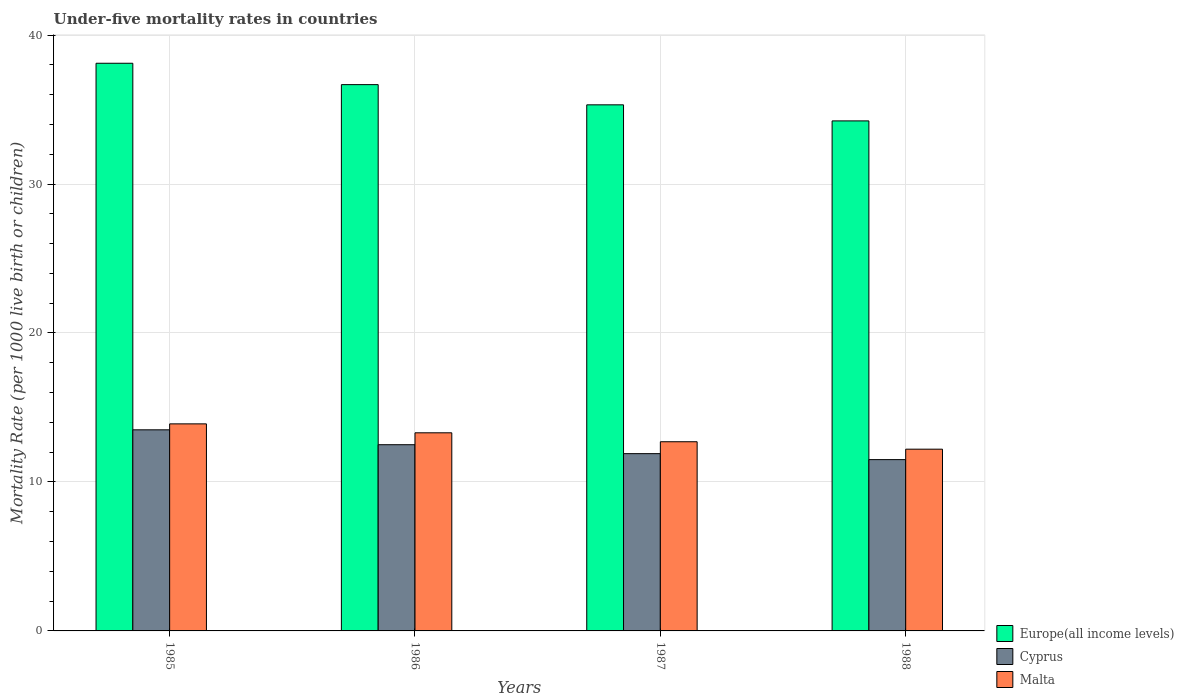How many different coloured bars are there?
Ensure brevity in your answer.  3. How many groups of bars are there?
Ensure brevity in your answer.  4. How many bars are there on the 2nd tick from the right?
Provide a succinct answer. 3. In how many cases, is the number of bars for a given year not equal to the number of legend labels?
Provide a short and direct response. 0. What is the under-five mortality rate in Cyprus in 1988?
Provide a short and direct response. 11.5. Across all years, what is the minimum under-five mortality rate in Malta?
Provide a short and direct response. 12.2. In which year was the under-five mortality rate in Malta maximum?
Ensure brevity in your answer.  1985. In which year was the under-five mortality rate in Europe(all income levels) minimum?
Your answer should be compact. 1988. What is the total under-five mortality rate in Europe(all income levels) in the graph?
Your response must be concise. 144.33. What is the difference between the under-five mortality rate in Europe(all income levels) in 1988 and the under-five mortality rate in Cyprus in 1986?
Make the answer very short. 21.74. What is the average under-five mortality rate in Europe(all income levels) per year?
Your response must be concise. 36.08. In the year 1988, what is the difference between the under-five mortality rate in Cyprus and under-five mortality rate in Europe(all income levels)?
Offer a very short reply. -22.74. What is the ratio of the under-five mortality rate in Europe(all income levels) in 1987 to that in 1988?
Keep it short and to the point. 1.03. What is the difference between the highest and the lowest under-five mortality rate in Malta?
Give a very brief answer. 1.7. In how many years, is the under-five mortality rate in Europe(all income levels) greater than the average under-five mortality rate in Europe(all income levels) taken over all years?
Your response must be concise. 2. Is the sum of the under-five mortality rate in Cyprus in 1985 and 1987 greater than the maximum under-five mortality rate in Europe(all income levels) across all years?
Keep it short and to the point. No. What does the 3rd bar from the left in 1986 represents?
Provide a succinct answer. Malta. What does the 2nd bar from the right in 1988 represents?
Ensure brevity in your answer.  Cyprus. Is it the case that in every year, the sum of the under-five mortality rate in Malta and under-five mortality rate in Europe(all income levels) is greater than the under-five mortality rate in Cyprus?
Give a very brief answer. Yes. Are all the bars in the graph horizontal?
Offer a terse response. No. What is the difference between two consecutive major ticks on the Y-axis?
Ensure brevity in your answer.  10. Does the graph contain any zero values?
Ensure brevity in your answer.  No. Does the graph contain grids?
Ensure brevity in your answer.  Yes. How many legend labels are there?
Provide a short and direct response. 3. What is the title of the graph?
Provide a succinct answer. Under-five mortality rates in countries. What is the label or title of the Y-axis?
Give a very brief answer. Mortality Rate (per 1000 live birth or children). What is the Mortality Rate (per 1000 live birth or children) of Europe(all income levels) in 1985?
Provide a short and direct response. 38.11. What is the Mortality Rate (per 1000 live birth or children) in Europe(all income levels) in 1986?
Your answer should be compact. 36.67. What is the Mortality Rate (per 1000 live birth or children) of Cyprus in 1986?
Provide a succinct answer. 12.5. What is the Mortality Rate (per 1000 live birth or children) of Europe(all income levels) in 1987?
Your response must be concise. 35.32. What is the Mortality Rate (per 1000 live birth or children) in Cyprus in 1987?
Your answer should be compact. 11.9. What is the Mortality Rate (per 1000 live birth or children) of Europe(all income levels) in 1988?
Keep it short and to the point. 34.24. What is the Mortality Rate (per 1000 live birth or children) of Cyprus in 1988?
Your answer should be very brief. 11.5. Across all years, what is the maximum Mortality Rate (per 1000 live birth or children) of Europe(all income levels)?
Your answer should be compact. 38.11. Across all years, what is the maximum Mortality Rate (per 1000 live birth or children) in Malta?
Provide a short and direct response. 13.9. Across all years, what is the minimum Mortality Rate (per 1000 live birth or children) in Europe(all income levels)?
Give a very brief answer. 34.24. Across all years, what is the minimum Mortality Rate (per 1000 live birth or children) of Cyprus?
Provide a short and direct response. 11.5. Across all years, what is the minimum Mortality Rate (per 1000 live birth or children) of Malta?
Ensure brevity in your answer.  12.2. What is the total Mortality Rate (per 1000 live birth or children) in Europe(all income levels) in the graph?
Your answer should be very brief. 144.33. What is the total Mortality Rate (per 1000 live birth or children) in Cyprus in the graph?
Your answer should be compact. 49.4. What is the total Mortality Rate (per 1000 live birth or children) in Malta in the graph?
Offer a terse response. 52.1. What is the difference between the Mortality Rate (per 1000 live birth or children) in Europe(all income levels) in 1985 and that in 1986?
Your answer should be compact. 1.44. What is the difference between the Mortality Rate (per 1000 live birth or children) of Cyprus in 1985 and that in 1986?
Your answer should be very brief. 1. What is the difference between the Mortality Rate (per 1000 live birth or children) in Europe(all income levels) in 1985 and that in 1987?
Provide a short and direct response. 2.79. What is the difference between the Mortality Rate (per 1000 live birth or children) of Europe(all income levels) in 1985 and that in 1988?
Your answer should be very brief. 3.87. What is the difference between the Mortality Rate (per 1000 live birth or children) in Europe(all income levels) in 1986 and that in 1987?
Your answer should be very brief. 1.36. What is the difference between the Mortality Rate (per 1000 live birth or children) of Malta in 1986 and that in 1987?
Ensure brevity in your answer.  0.6. What is the difference between the Mortality Rate (per 1000 live birth or children) in Europe(all income levels) in 1986 and that in 1988?
Keep it short and to the point. 2.43. What is the difference between the Mortality Rate (per 1000 live birth or children) in Cyprus in 1986 and that in 1988?
Provide a short and direct response. 1. What is the difference between the Mortality Rate (per 1000 live birth or children) in Europe(all income levels) in 1987 and that in 1988?
Your answer should be very brief. 1.08. What is the difference between the Mortality Rate (per 1000 live birth or children) in Cyprus in 1987 and that in 1988?
Your answer should be very brief. 0.4. What is the difference between the Mortality Rate (per 1000 live birth or children) of Europe(all income levels) in 1985 and the Mortality Rate (per 1000 live birth or children) of Cyprus in 1986?
Ensure brevity in your answer.  25.61. What is the difference between the Mortality Rate (per 1000 live birth or children) in Europe(all income levels) in 1985 and the Mortality Rate (per 1000 live birth or children) in Malta in 1986?
Offer a very short reply. 24.81. What is the difference between the Mortality Rate (per 1000 live birth or children) in Cyprus in 1985 and the Mortality Rate (per 1000 live birth or children) in Malta in 1986?
Your answer should be very brief. 0.2. What is the difference between the Mortality Rate (per 1000 live birth or children) of Europe(all income levels) in 1985 and the Mortality Rate (per 1000 live birth or children) of Cyprus in 1987?
Your response must be concise. 26.21. What is the difference between the Mortality Rate (per 1000 live birth or children) in Europe(all income levels) in 1985 and the Mortality Rate (per 1000 live birth or children) in Malta in 1987?
Your answer should be very brief. 25.41. What is the difference between the Mortality Rate (per 1000 live birth or children) of Cyprus in 1985 and the Mortality Rate (per 1000 live birth or children) of Malta in 1987?
Offer a terse response. 0.8. What is the difference between the Mortality Rate (per 1000 live birth or children) in Europe(all income levels) in 1985 and the Mortality Rate (per 1000 live birth or children) in Cyprus in 1988?
Make the answer very short. 26.61. What is the difference between the Mortality Rate (per 1000 live birth or children) in Europe(all income levels) in 1985 and the Mortality Rate (per 1000 live birth or children) in Malta in 1988?
Give a very brief answer. 25.91. What is the difference between the Mortality Rate (per 1000 live birth or children) of Cyprus in 1985 and the Mortality Rate (per 1000 live birth or children) of Malta in 1988?
Your response must be concise. 1.3. What is the difference between the Mortality Rate (per 1000 live birth or children) in Europe(all income levels) in 1986 and the Mortality Rate (per 1000 live birth or children) in Cyprus in 1987?
Provide a succinct answer. 24.77. What is the difference between the Mortality Rate (per 1000 live birth or children) in Europe(all income levels) in 1986 and the Mortality Rate (per 1000 live birth or children) in Malta in 1987?
Provide a short and direct response. 23.97. What is the difference between the Mortality Rate (per 1000 live birth or children) in Europe(all income levels) in 1986 and the Mortality Rate (per 1000 live birth or children) in Cyprus in 1988?
Provide a short and direct response. 25.17. What is the difference between the Mortality Rate (per 1000 live birth or children) in Europe(all income levels) in 1986 and the Mortality Rate (per 1000 live birth or children) in Malta in 1988?
Provide a succinct answer. 24.47. What is the difference between the Mortality Rate (per 1000 live birth or children) of Cyprus in 1986 and the Mortality Rate (per 1000 live birth or children) of Malta in 1988?
Keep it short and to the point. 0.3. What is the difference between the Mortality Rate (per 1000 live birth or children) of Europe(all income levels) in 1987 and the Mortality Rate (per 1000 live birth or children) of Cyprus in 1988?
Make the answer very short. 23.82. What is the difference between the Mortality Rate (per 1000 live birth or children) of Europe(all income levels) in 1987 and the Mortality Rate (per 1000 live birth or children) of Malta in 1988?
Offer a terse response. 23.12. What is the average Mortality Rate (per 1000 live birth or children) in Europe(all income levels) per year?
Give a very brief answer. 36.08. What is the average Mortality Rate (per 1000 live birth or children) of Cyprus per year?
Ensure brevity in your answer.  12.35. What is the average Mortality Rate (per 1000 live birth or children) in Malta per year?
Provide a short and direct response. 13.03. In the year 1985, what is the difference between the Mortality Rate (per 1000 live birth or children) of Europe(all income levels) and Mortality Rate (per 1000 live birth or children) of Cyprus?
Make the answer very short. 24.61. In the year 1985, what is the difference between the Mortality Rate (per 1000 live birth or children) of Europe(all income levels) and Mortality Rate (per 1000 live birth or children) of Malta?
Keep it short and to the point. 24.21. In the year 1985, what is the difference between the Mortality Rate (per 1000 live birth or children) in Cyprus and Mortality Rate (per 1000 live birth or children) in Malta?
Make the answer very short. -0.4. In the year 1986, what is the difference between the Mortality Rate (per 1000 live birth or children) of Europe(all income levels) and Mortality Rate (per 1000 live birth or children) of Cyprus?
Offer a terse response. 24.17. In the year 1986, what is the difference between the Mortality Rate (per 1000 live birth or children) of Europe(all income levels) and Mortality Rate (per 1000 live birth or children) of Malta?
Offer a very short reply. 23.37. In the year 1987, what is the difference between the Mortality Rate (per 1000 live birth or children) of Europe(all income levels) and Mortality Rate (per 1000 live birth or children) of Cyprus?
Offer a terse response. 23.42. In the year 1987, what is the difference between the Mortality Rate (per 1000 live birth or children) in Europe(all income levels) and Mortality Rate (per 1000 live birth or children) in Malta?
Offer a terse response. 22.62. In the year 1988, what is the difference between the Mortality Rate (per 1000 live birth or children) of Europe(all income levels) and Mortality Rate (per 1000 live birth or children) of Cyprus?
Provide a short and direct response. 22.74. In the year 1988, what is the difference between the Mortality Rate (per 1000 live birth or children) in Europe(all income levels) and Mortality Rate (per 1000 live birth or children) in Malta?
Ensure brevity in your answer.  22.04. In the year 1988, what is the difference between the Mortality Rate (per 1000 live birth or children) in Cyprus and Mortality Rate (per 1000 live birth or children) in Malta?
Give a very brief answer. -0.7. What is the ratio of the Mortality Rate (per 1000 live birth or children) of Europe(all income levels) in 1985 to that in 1986?
Provide a succinct answer. 1.04. What is the ratio of the Mortality Rate (per 1000 live birth or children) in Malta in 1985 to that in 1986?
Ensure brevity in your answer.  1.05. What is the ratio of the Mortality Rate (per 1000 live birth or children) in Europe(all income levels) in 1985 to that in 1987?
Offer a terse response. 1.08. What is the ratio of the Mortality Rate (per 1000 live birth or children) in Cyprus in 1985 to that in 1987?
Give a very brief answer. 1.13. What is the ratio of the Mortality Rate (per 1000 live birth or children) of Malta in 1985 to that in 1987?
Keep it short and to the point. 1.09. What is the ratio of the Mortality Rate (per 1000 live birth or children) of Europe(all income levels) in 1985 to that in 1988?
Make the answer very short. 1.11. What is the ratio of the Mortality Rate (per 1000 live birth or children) of Cyprus in 1985 to that in 1988?
Keep it short and to the point. 1.17. What is the ratio of the Mortality Rate (per 1000 live birth or children) of Malta in 1985 to that in 1988?
Provide a short and direct response. 1.14. What is the ratio of the Mortality Rate (per 1000 live birth or children) of Europe(all income levels) in 1986 to that in 1987?
Keep it short and to the point. 1.04. What is the ratio of the Mortality Rate (per 1000 live birth or children) of Cyprus in 1986 to that in 1987?
Provide a succinct answer. 1.05. What is the ratio of the Mortality Rate (per 1000 live birth or children) in Malta in 1986 to that in 1987?
Your answer should be very brief. 1.05. What is the ratio of the Mortality Rate (per 1000 live birth or children) in Europe(all income levels) in 1986 to that in 1988?
Ensure brevity in your answer.  1.07. What is the ratio of the Mortality Rate (per 1000 live birth or children) in Cyprus in 1986 to that in 1988?
Your response must be concise. 1.09. What is the ratio of the Mortality Rate (per 1000 live birth or children) of Malta in 1986 to that in 1988?
Provide a succinct answer. 1.09. What is the ratio of the Mortality Rate (per 1000 live birth or children) in Europe(all income levels) in 1987 to that in 1988?
Your response must be concise. 1.03. What is the ratio of the Mortality Rate (per 1000 live birth or children) of Cyprus in 1987 to that in 1988?
Provide a succinct answer. 1.03. What is the ratio of the Mortality Rate (per 1000 live birth or children) in Malta in 1987 to that in 1988?
Offer a very short reply. 1.04. What is the difference between the highest and the second highest Mortality Rate (per 1000 live birth or children) of Europe(all income levels)?
Give a very brief answer. 1.44. What is the difference between the highest and the second highest Mortality Rate (per 1000 live birth or children) in Cyprus?
Provide a succinct answer. 1. What is the difference between the highest and the second highest Mortality Rate (per 1000 live birth or children) of Malta?
Your answer should be very brief. 0.6. What is the difference between the highest and the lowest Mortality Rate (per 1000 live birth or children) in Europe(all income levels)?
Offer a very short reply. 3.87. What is the difference between the highest and the lowest Mortality Rate (per 1000 live birth or children) in Malta?
Give a very brief answer. 1.7. 